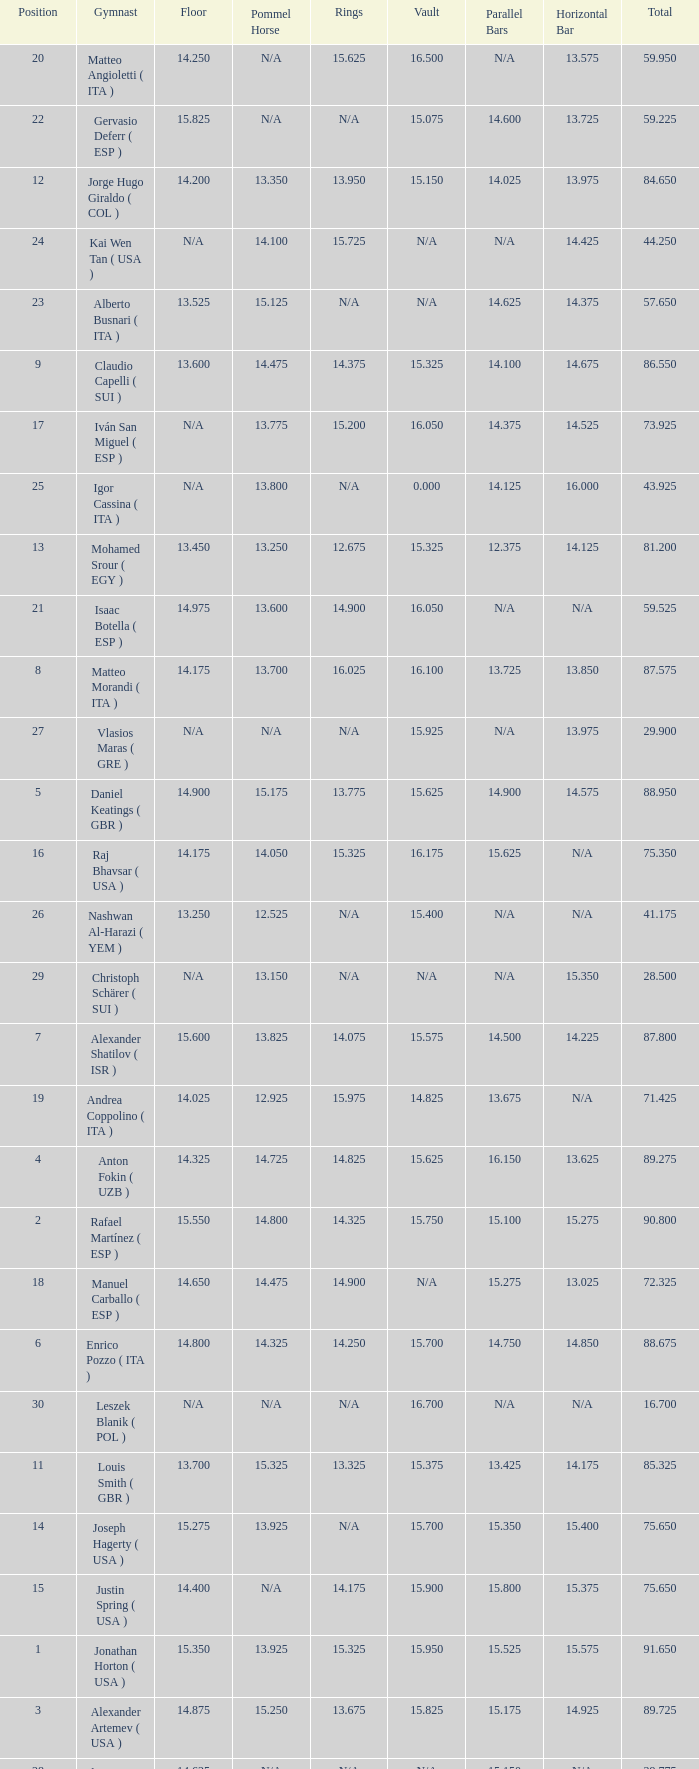If the horizontal bar is n/a and the floor is 14.175, what is the number for the parallel bars? 15.625. Would you be able to parse every entry in this table? {'header': ['Position', 'Gymnast', 'Floor', 'Pommel Horse', 'Rings', 'Vault', 'Parallel Bars', 'Horizontal Bar', 'Total'], 'rows': [['20', 'Matteo Angioletti ( ITA )', '14.250', 'N/A', '15.625', '16.500', 'N/A', '13.575', '59.950'], ['22', 'Gervasio Deferr ( ESP )', '15.825', 'N/A', 'N/A', '15.075', '14.600', '13.725', '59.225'], ['12', 'Jorge Hugo Giraldo ( COL )', '14.200', '13.350', '13.950', '15.150', '14.025', '13.975', '84.650'], ['24', 'Kai Wen Tan ( USA )', 'N/A', '14.100', '15.725', 'N/A', 'N/A', '14.425', '44.250'], ['23', 'Alberto Busnari ( ITA )', '13.525', '15.125', 'N/A', 'N/A', '14.625', '14.375', '57.650'], ['9', 'Claudio Capelli ( SUI )', '13.600', '14.475', '14.375', '15.325', '14.100', '14.675', '86.550'], ['17', 'Iván San Miguel ( ESP )', 'N/A', '13.775', '15.200', '16.050', '14.375', '14.525', '73.925'], ['25', 'Igor Cassina ( ITA )', 'N/A', '13.800', 'N/A', '0.000', '14.125', '16.000', '43.925'], ['13', 'Mohamed Srour ( EGY )', '13.450', '13.250', '12.675', '15.325', '12.375', '14.125', '81.200'], ['21', 'Isaac Botella ( ESP )', '14.975', '13.600', '14.900', '16.050', 'N/A', 'N/A', '59.525'], ['8', 'Matteo Morandi ( ITA )', '14.175', '13.700', '16.025', '16.100', '13.725', '13.850', '87.575'], ['27', 'Vlasios Maras ( GRE )', 'N/A', 'N/A', 'N/A', '15.925', 'N/A', '13.975', '29.900'], ['5', 'Daniel Keatings ( GBR )', '14.900', '15.175', '13.775', '15.625', '14.900', '14.575', '88.950'], ['16', 'Raj Bhavsar ( USA )', '14.175', '14.050', '15.325', '16.175', '15.625', 'N/A', '75.350'], ['26', 'Nashwan Al-Harazi ( YEM )', '13.250', '12.525', 'N/A', '15.400', 'N/A', 'N/A', '41.175'], ['29', 'Christoph Schärer ( SUI )', 'N/A', '13.150', 'N/A', 'N/A', 'N/A', '15.350', '28.500'], ['7', 'Alexander Shatilov ( ISR )', '15.600', '13.825', '14.075', '15.575', '14.500', '14.225', '87.800'], ['19', 'Andrea Coppolino ( ITA )', '14.025', '12.925', '15.975', '14.825', '13.675', 'N/A', '71.425'], ['4', 'Anton Fokin ( UZB )', '14.325', '14.725', '14.825', '15.625', '16.150', '13.625', '89.275'], ['2', 'Rafael Martínez ( ESP )', '15.550', '14.800', '14.325', '15.750', '15.100', '15.275', '90.800'], ['18', 'Manuel Carballo ( ESP )', '14.650', '14.475', '14.900', 'N/A', '15.275', '13.025', '72.325'], ['6', 'Enrico Pozzo ( ITA )', '14.800', '14.325', '14.250', '15.700', '14.750', '14.850', '88.675'], ['30', 'Leszek Blanik ( POL )', 'N/A', 'N/A', 'N/A', '16.700', 'N/A', 'N/A', '16.700'], ['11', 'Louis Smith ( GBR )', '13.700', '15.325', '13.325', '15.375', '13.425', '14.175', '85.325'], ['14', 'Joseph Hagerty ( USA )', '15.275', '13.925', 'N/A', '15.700', '15.350', '15.400', '75.650'], ['15', 'Justin Spring ( USA )', '14.400', 'N/A', '14.175', '15.900', '15.800', '15.375', '75.650'], ['1', 'Jonathan Horton ( USA )', '15.350', '13.925', '15.325', '15.950', '15.525', '15.575', '91.650'], ['3', 'Alexander Artemev ( USA )', '14.875', '15.250', '13.675', '15.825', '15.175', '14.925', '89.725'], ['28', 'Ilia Giorgadze ( GEO )', '14.625', 'N/A', 'N/A', 'N/A', '15.150', 'N/A', '29.775'], ['10', 'Sergio Muñoz ( ESP )', '14.575', '12.700', '15.150', '16.100', '13.675', '13.300', '85.500']]} 